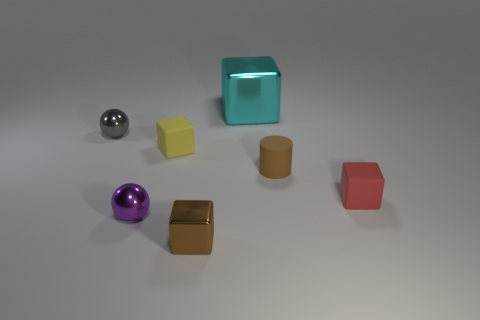Is there any other thing that has the same shape as the tiny brown rubber thing? While the provided answer was simply 'no', it would be helpful to note that the shape of the object in question—a cylindrical item that appears to be a small brown cup or container—does not have an exact match in shape among the visible objects. However, the silver sphere and the purple sphere share a common shape as they are both spherical, while the various blocks each have their distinct cuboid dimensions. So, although dimensions and specific attributes vary, there are some general shape similarities like sphericity and cuboid forms among the items. 